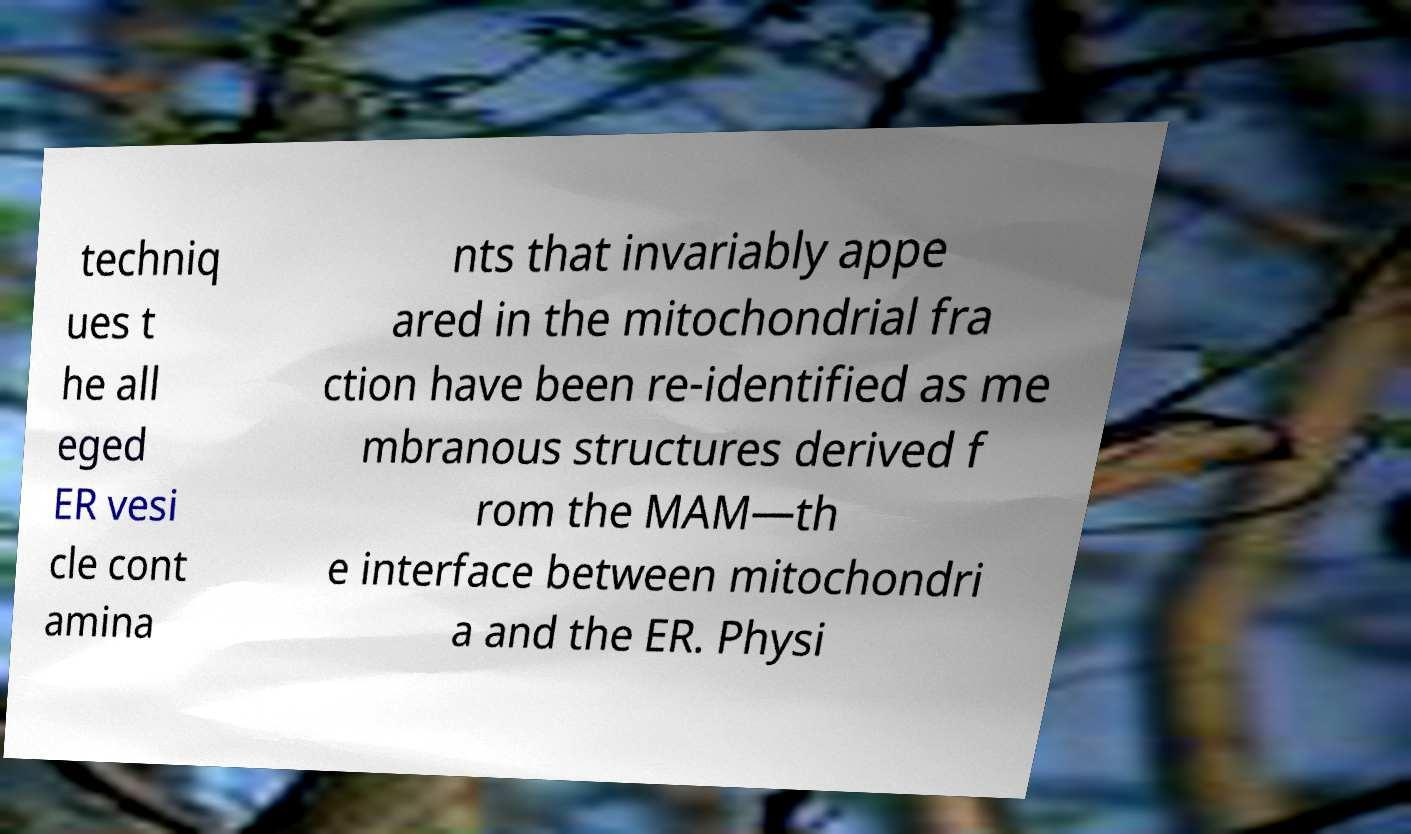I need the written content from this picture converted into text. Can you do that? techniq ues t he all eged ER vesi cle cont amina nts that invariably appe ared in the mitochondrial fra ction have been re-identified as me mbranous structures derived f rom the MAM—th e interface between mitochondri a and the ER. Physi 